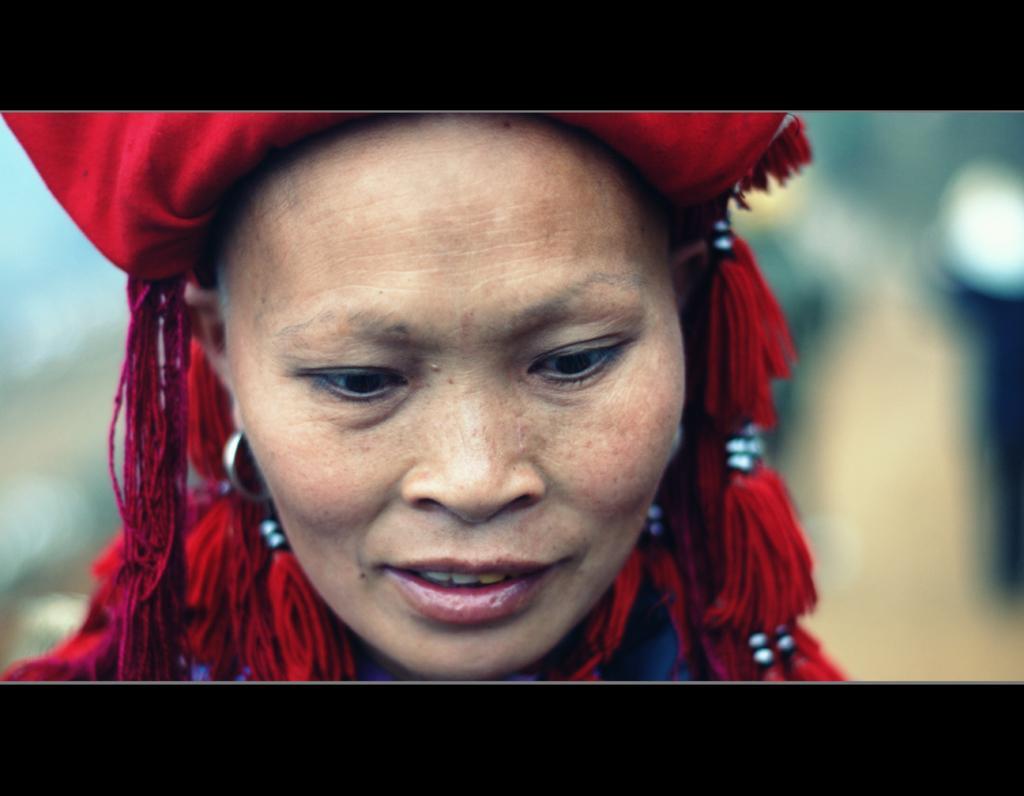In one or two sentences, can you explain what this image depicts? A woman is there, she wore red color cap. 